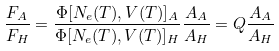<formula> <loc_0><loc_0><loc_500><loc_500>\frac { F _ { A } } { F _ { H } } = \frac { \Phi [ N _ { e } ( T ) , V ( T ) ] _ { A } } { \Phi [ N _ { e } ( T ) , V ( T ) ] _ { H } } \frac { A _ { A } } { A _ { H } } = Q \frac { A _ { A } } { A _ { H } }</formula> 